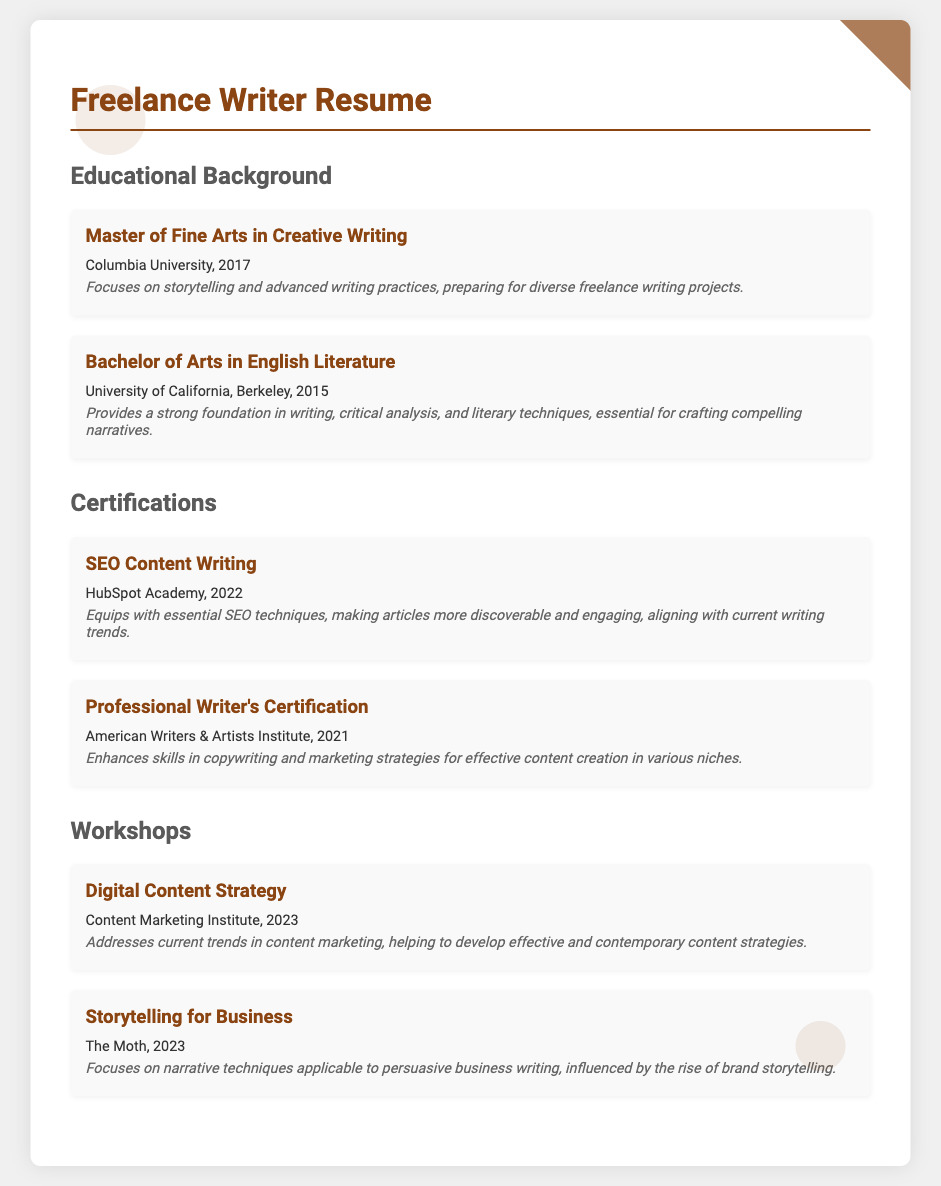What degree was obtained in 2017? The document specifies that a Master of Fine Arts in Creative Writing was obtained in 2017.
Answer: Master of Fine Arts in Creative Writing Which university awarded the Bachelor's degree? The document mentions that the degree was awarded by the University of California, Berkeley.
Answer: University of California, Berkeley What certification was earned from HubSpot Academy? The resume states that the SEO Content Writing certification was earned from HubSpot Academy.
Answer: SEO Content Writing In what year was the Professional Writer's Certification obtained? The document indicates that the Professional Writer's Certification was obtained in 2021.
Answer: 2021 Which workshop focuses on narrative techniques for business writing? The workshop titled Storytelling for Business is focused on narrative techniques for persuasive writing.
Answer: Storytelling for Business What is the focus of the Master's program mentioned? The program focuses on storytelling and advanced writing practices, relevant to freelance writing projects.
Answer: Storytelling and advanced writing practices How many workshops are listed in the document? The document includes two workshops listed under the Workshops section.
Answer: Two What year was the Digital Content Strategy workshop held? The resume reveals that the Digital Content Strategy workshop took place in 2023.
Answer: 2023 